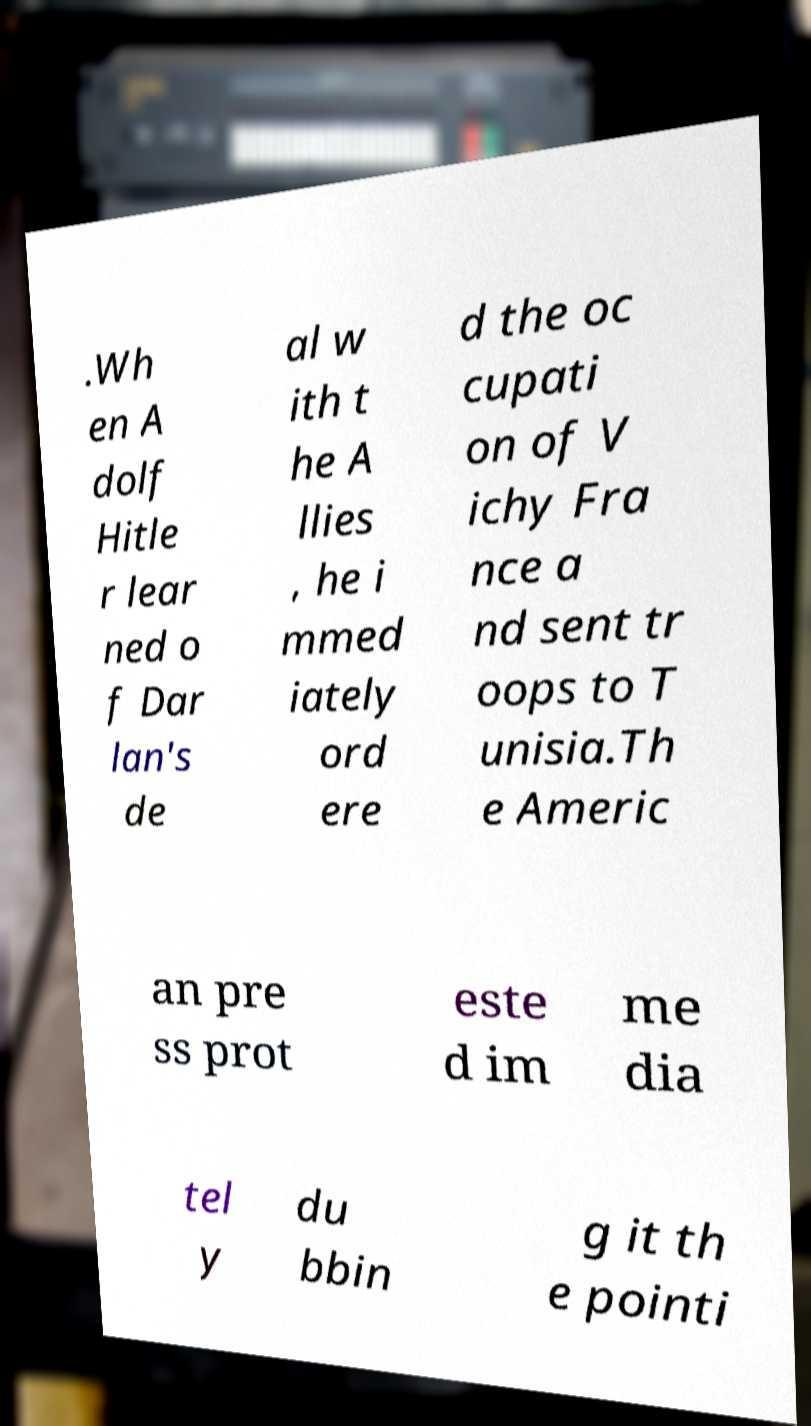For documentation purposes, I need the text within this image transcribed. Could you provide that? .Wh en A dolf Hitle r lear ned o f Dar lan's de al w ith t he A llies , he i mmed iately ord ere d the oc cupati on of V ichy Fra nce a nd sent tr oops to T unisia.Th e Americ an pre ss prot este d im me dia tel y du bbin g it th e pointi 